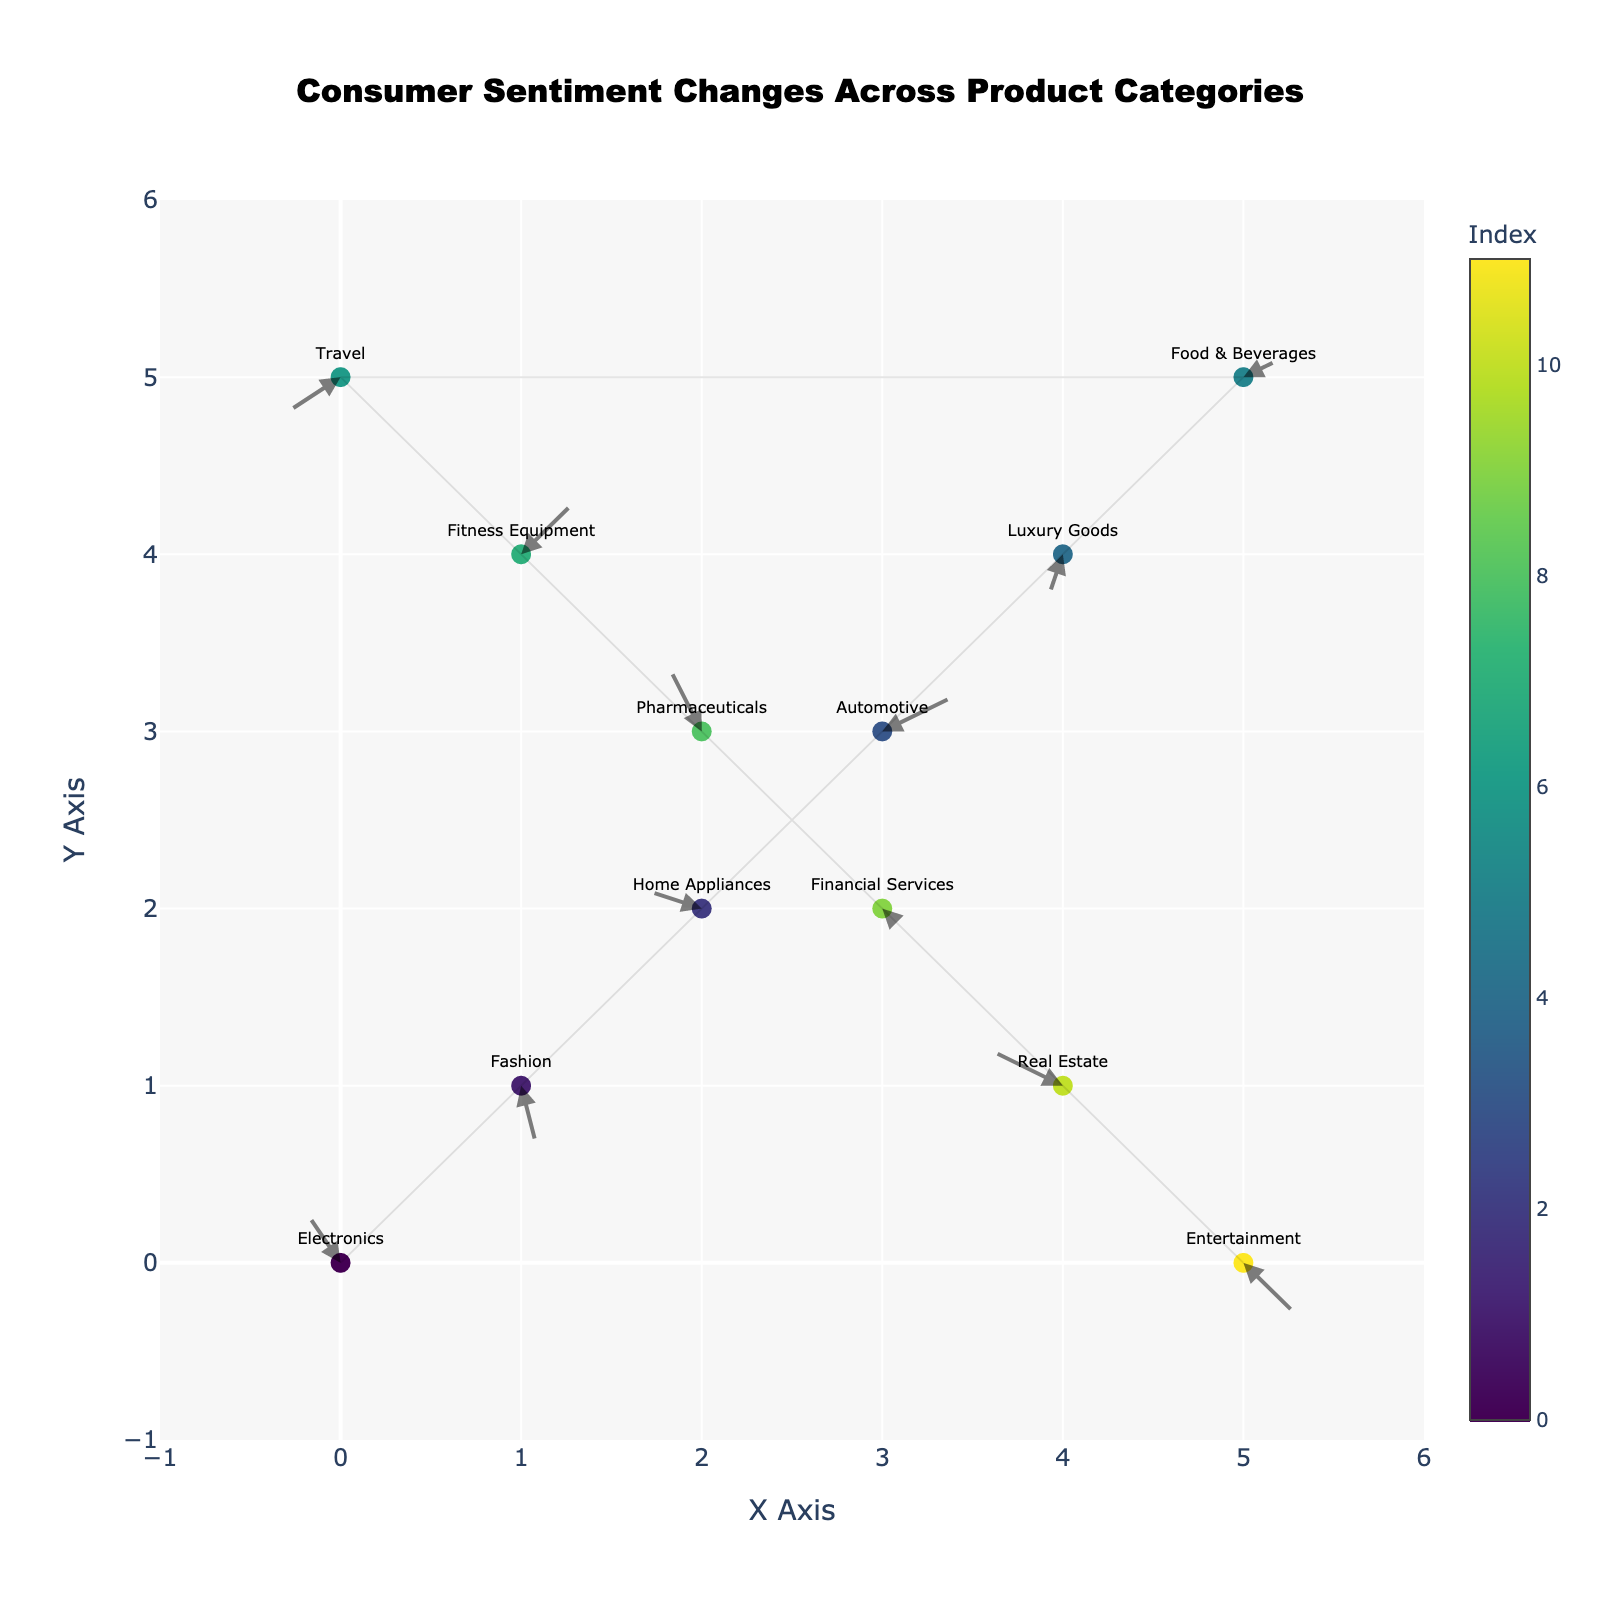What's the title of the figure? The title is displayed prominently at the top of the figure and it reads "Consumer Sentiment Changes Across Product Categories".
Answer: Consumer Sentiment Changes Across Product Categories How many product categories are represented in the figure? By counting the number of arrows or data points in the figure, we see that there are 12 product categories represented. The categories include Electronics, Fashion, Home Appliances, Automotive, Luxury Goods, Food & Beverages, Travel, Fitness Equipment, Pharmaceuticals, Financial Services, Real Estate, and Entertainment.
Answer: 12 Which category has an arrow moving upwards from the position (1, 4)? By observing the position and direction of the arrows, we see that the arrow at (1, 4) moving upwards corresponds to Fitness Equipment. The upward movement is indicated by the positive y-component (0.3).
Answer: Fitness Equipment What is the direction of consumer sentiment change for the category at (0, 5)? The category at (0, 5) is Travel, and its arrow moves to (-0.3, -0.2). This indicates a leftward and downward movement in consumer sentiment.
Answer: Leftward and downward Which category has the largest positive x-component of movement and what is its value? By scanning the u-components of the arrows, we see that the largest positive x-component of movement is 0.4, which belongs to the Automotive category.
Answer: Automotive, 0.4 How many categories have a negative y-component of movement? By counting the arrows with a negative v-component, we observe that categories with negative y-components are Fashion, Luxury Goods, Travel, Financial Services, and Entertainment. This makes a total of 5 categories.
Answer: 5 Which category shows both negative x and y movements and where is it positioned? Observing the arrows, we can see that the category Luxury Goods at (4, 4) shows both negative x and y movements with the components (-0.1, -0.3).
Answer: Luxury Goods, (4, 4) Which product category has the smallest movement in terms of magnitude, and what is that magnitude? Calculating the magnitude of each movement vector \( \sqrt{u^2 + v^2} \), we find that the smallest magnitude is for the Financial Services category, with components (0.1, -0.1). The magnitude is \(\sqrt{0.1^2 + (-0.1)^2} = \sqrt{0.02} \approx 0.14\).
Answer: Financial Services, 0.14 What direction of movement does the arrow for Home Appliances indicate? The Home Appliances arrow at (2, 2) points with components (-0.3, 0.1), which indicates a movement to the left (negative x-component) and slightly upwards (positive y-component).
Answer: Left and slightly upwards Which category at position (5, 0) shows its consumer sentiment movement downwards and to the right? The category at position (5, 0) is Entertainment, with the arrow components (0.3, -0.3), indicating a movement to the right (positive x-component) and downwards (negative y-component).
Answer: Entertainment 